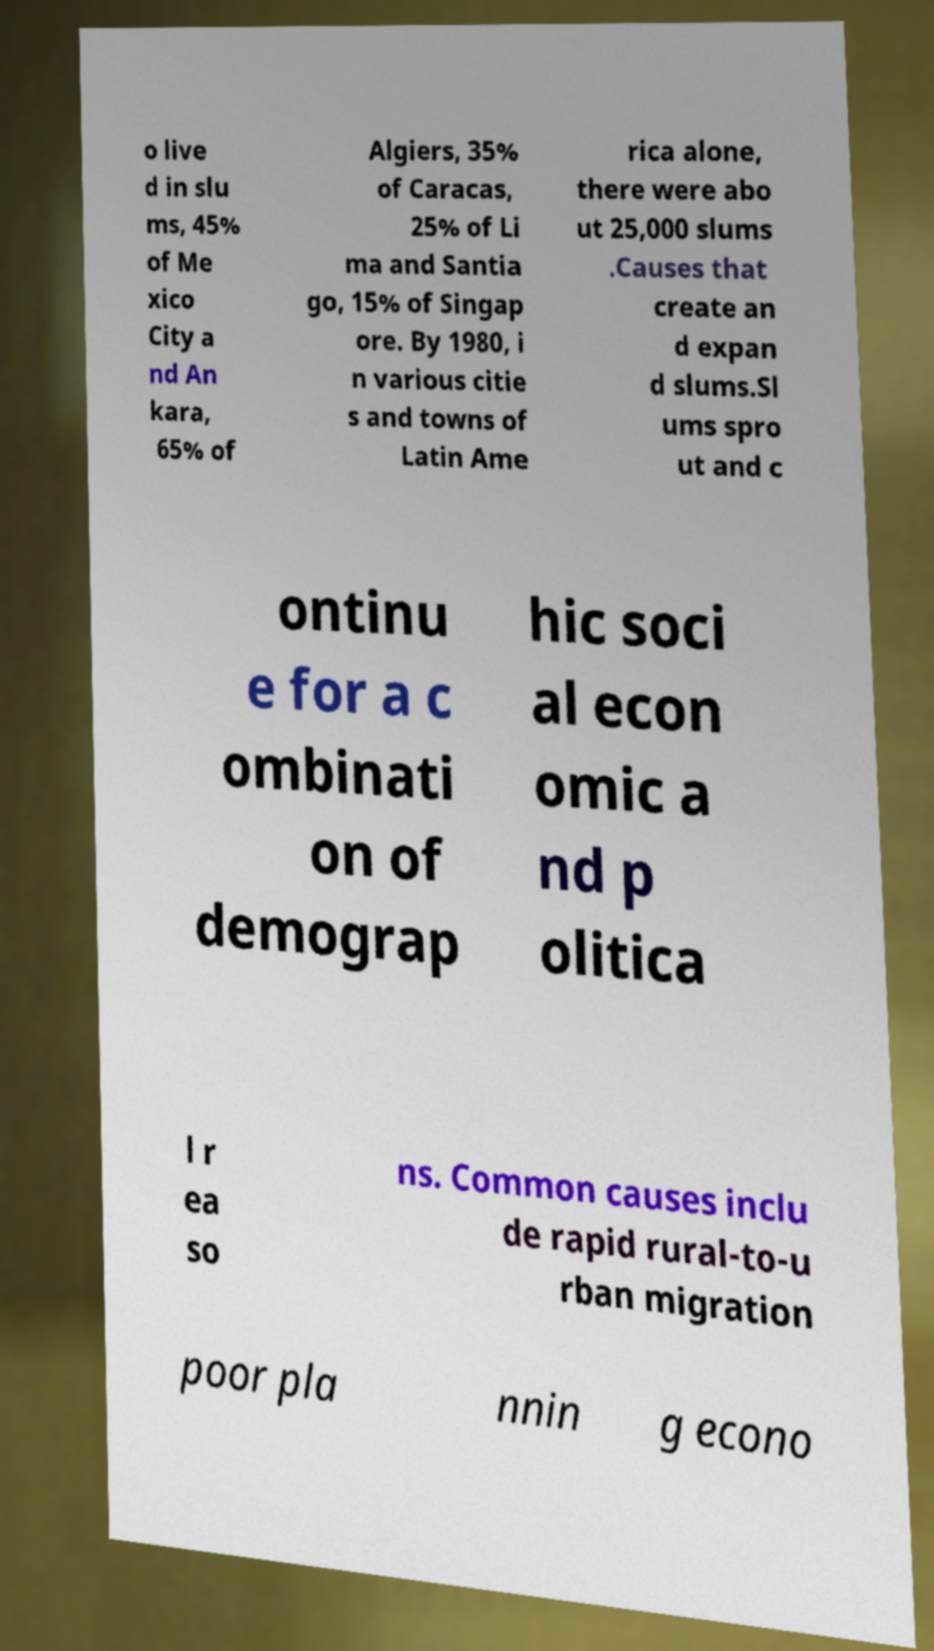Could you assist in decoding the text presented in this image and type it out clearly? o live d in slu ms, 45% of Me xico City a nd An kara, 65% of Algiers, 35% of Caracas, 25% of Li ma and Santia go, 15% of Singap ore. By 1980, i n various citie s and towns of Latin Ame rica alone, there were abo ut 25,000 slums .Causes that create an d expan d slums.Sl ums spro ut and c ontinu e for a c ombinati on of demograp hic soci al econ omic a nd p olitica l r ea so ns. Common causes inclu de rapid rural-to-u rban migration poor pla nnin g econo 